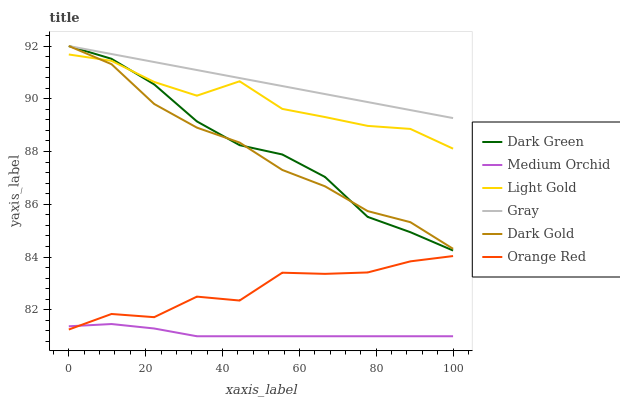Does Medium Orchid have the minimum area under the curve?
Answer yes or no. Yes. Does Gray have the maximum area under the curve?
Answer yes or no. Yes. Does Dark Gold have the minimum area under the curve?
Answer yes or no. No. Does Dark Gold have the maximum area under the curve?
Answer yes or no. No. Is Gray the smoothest?
Answer yes or no. Yes. Is Orange Red the roughest?
Answer yes or no. Yes. Is Dark Gold the smoothest?
Answer yes or no. No. Is Dark Gold the roughest?
Answer yes or no. No. Does Medium Orchid have the lowest value?
Answer yes or no. Yes. Does Dark Gold have the lowest value?
Answer yes or no. No. Does Dark Green have the highest value?
Answer yes or no. Yes. Does Medium Orchid have the highest value?
Answer yes or no. No. Is Medium Orchid less than Dark Gold?
Answer yes or no. Yes. Is Gray greater than Orange Red?
Answer yes or no. Yes. Does Dark Gold intersect Dark Green?
Answer yes or no. Yes. Is Dark Gold less than Dark Green?
Answer yes or no. No. Is Dark Gold greater than Dark Green?
Answer yes or no. No. Does Medium Orchid intersect Dark Gold?
Answer yes or no. No. 